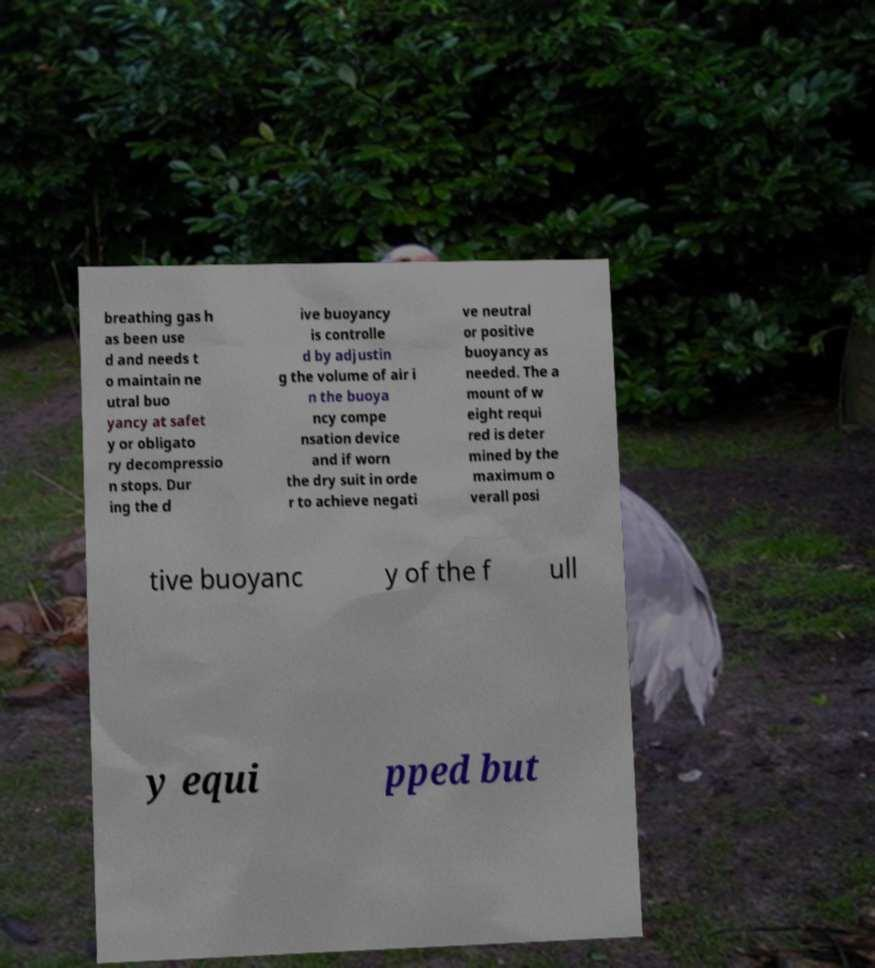Could you extract and type out the text from this image? breathing gas h as been use d and needs t o maintain ne utral buo yancy at safet y or obligato ry decompressio n stops. Dur ing the d ive buoyancy is controlle d by adjustin g the volume of air i n the buoya ncy compe nsation device and if worn the dry suit in orde r to achieve negati ve neutral or positive buoyancy as needed. The a mount of w eight requi red is deter mined by the maximum o verall posi tive buoyanc y of the f ull y equi pped but 